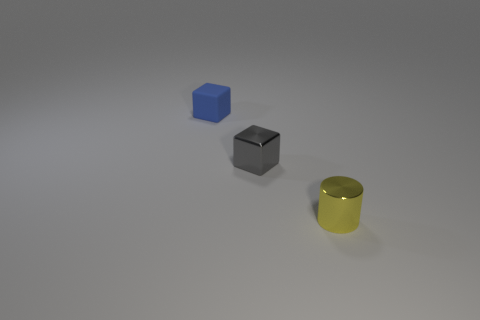Add 1 tiny blue matte cubes. How many objects exist? 4 Subtract all blocks. How many objects are left? 1 Subtract all brown rubber balls. Subtract all yellow cylinders. How many objects are left? 2 Add 2 blue things. How many blue things are left? 3 Add 1 small gray objects. How many small gray objects exist? 2 Subtract 0 blue cylinders. How many objects are left? 3 